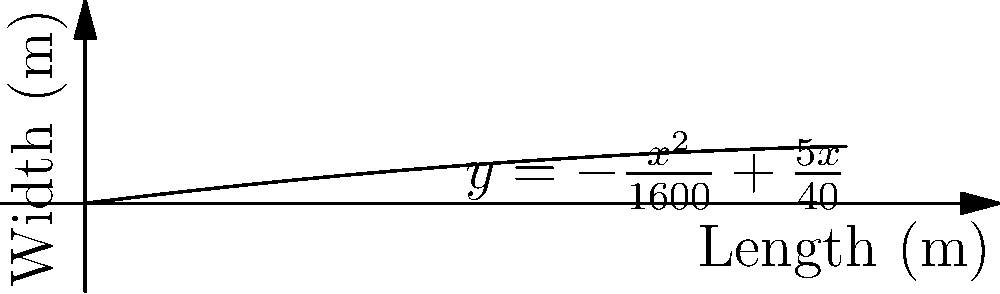As a Nigerian social media influencer supporting agricultural development, you're advising on maximizing crop yield in a rectangular field. The field's width (in meters) is given by the function $y = -\frac{x^2}{1600} + \frac{5x}{40}$, where $x$ is the length. What dimensions will maximize the area of the field, and what is this maximum area? Let's approach this step-by-step:

1) The area of a rectangle is given by $A = xy$. In this case, $y = -\frac{x^2}{1600} + \frac{5x}{40}$.

2) Substituting y into the area formula:
   $A(x) = x(-\frac{x^2}{1600} + \frac{5x}{40}) = -\frac{x^3}{1600} + \frac{5x^2}{40}$

3) To find the maximum, we need to find where $\frac{dA}{dx} = 0$:
   $\frac{dA}{dx} = -\frac{3x^2}{1600} + \frac{10x}{40} = -\frac{3x^2}{1600} + \frac{x}{4}$

4) Set this equal to zero:
   $-\frac{3x^2}{1600} + \frac{x}{4} = 0$

5) Multiply both sides by 1600:
   $-3x^2 + 400x = 0$

6) Factor out x:
   $x(-3x + 400) = 0$

7) Solve for x:
   $x = 0$ or $x = \frac{400}{3} \approx 133.33$

8) The solution $x = 0$ doesn't make sense for a field, so we use $x = \frac{400}{3}$.

9) To find y, substitute this x value:
   $y = -\frac{(400/3)^2}{1600} + \frac{5(400/3)}{40} = -\frac{160000}{14400} + \frac{2000}{120} = -\frac{100}{9} + \frac{50}{3} = \frac{50}{9}$

10) The maximum area is:
    $A = xy = \frac{400}{3} \cdot \frac{50}{9} = \frac{20000}{27} \approx 740.74$ square meters
Answer: Length: $\frac{400}{3}$ m, Width: $\frac{50}{9}$ m, Maximum Area: $\frac{20000}{27}$ m² 